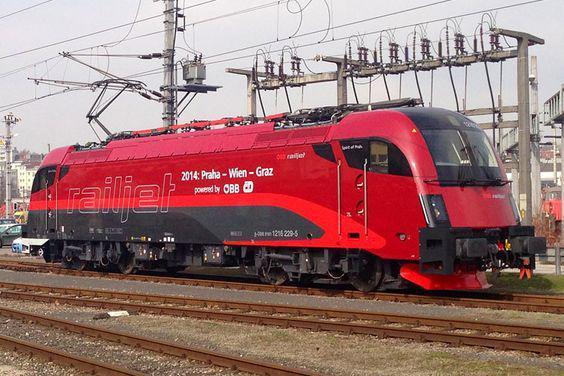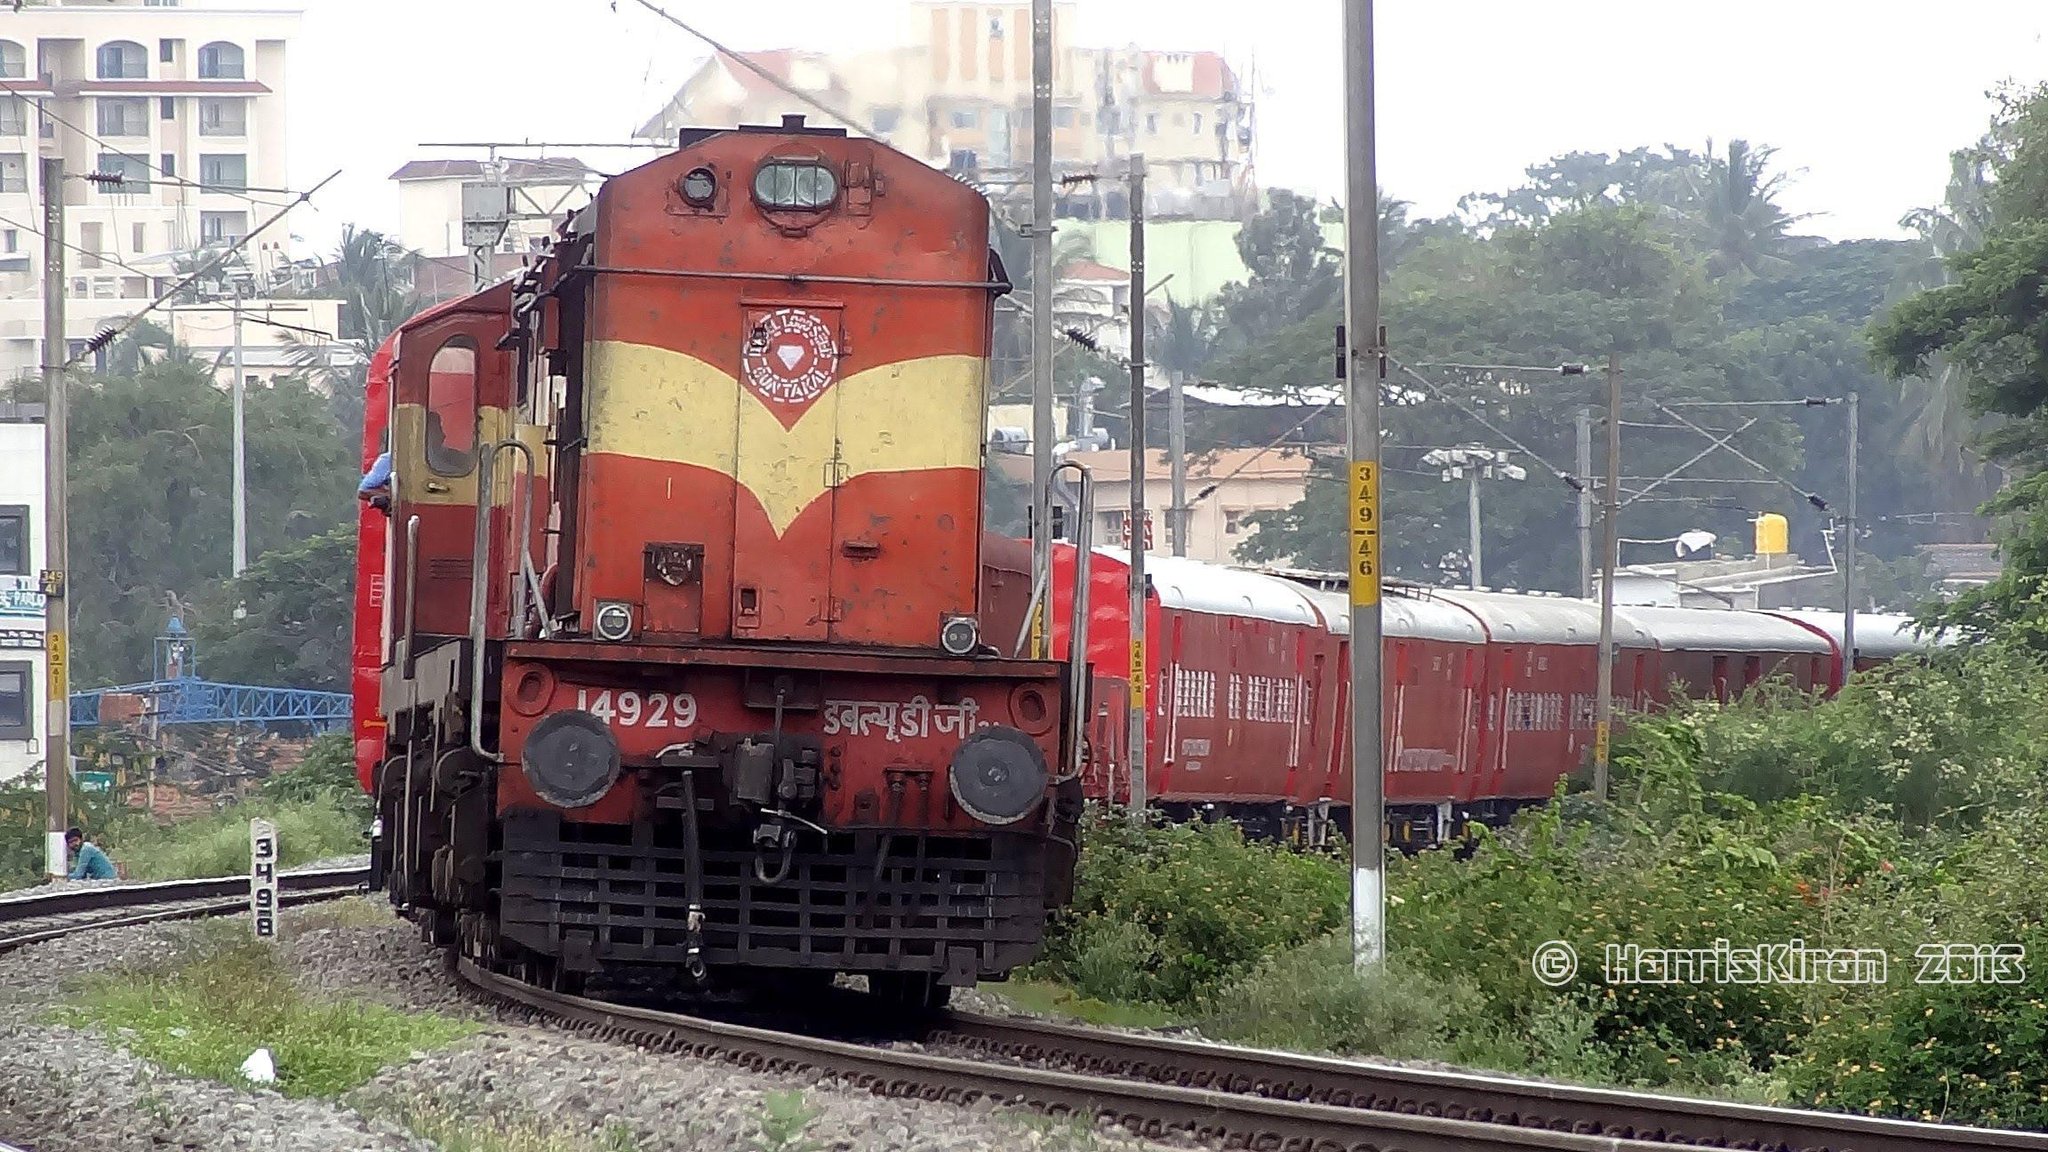The first image is the image on the left, the second image is the image on the right. Considering the images on both sides, is "Both trains are predominately red headed in the same direction." valid? Answer yes or no. Yes. The first image is the image on the left, the second image is the image on the right. For the images displayed, is the sentence "Each image shows a predominantly orange-red train, and no train has its front aimed leftward." factually correct? Answer yes or no. Yes. 